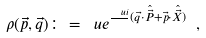<formula> <loc_0><loc_0><loc_500><loc_500>\rho ( \vec { p } , \vec { q } ) \colon = \ u e ^ { \frac { \ u i } { } ( \vec { q } \cdot \hat { \vec { P } } + \vec { p } \cdot \hat { \vec { X } } ) } \ ,</formula> 